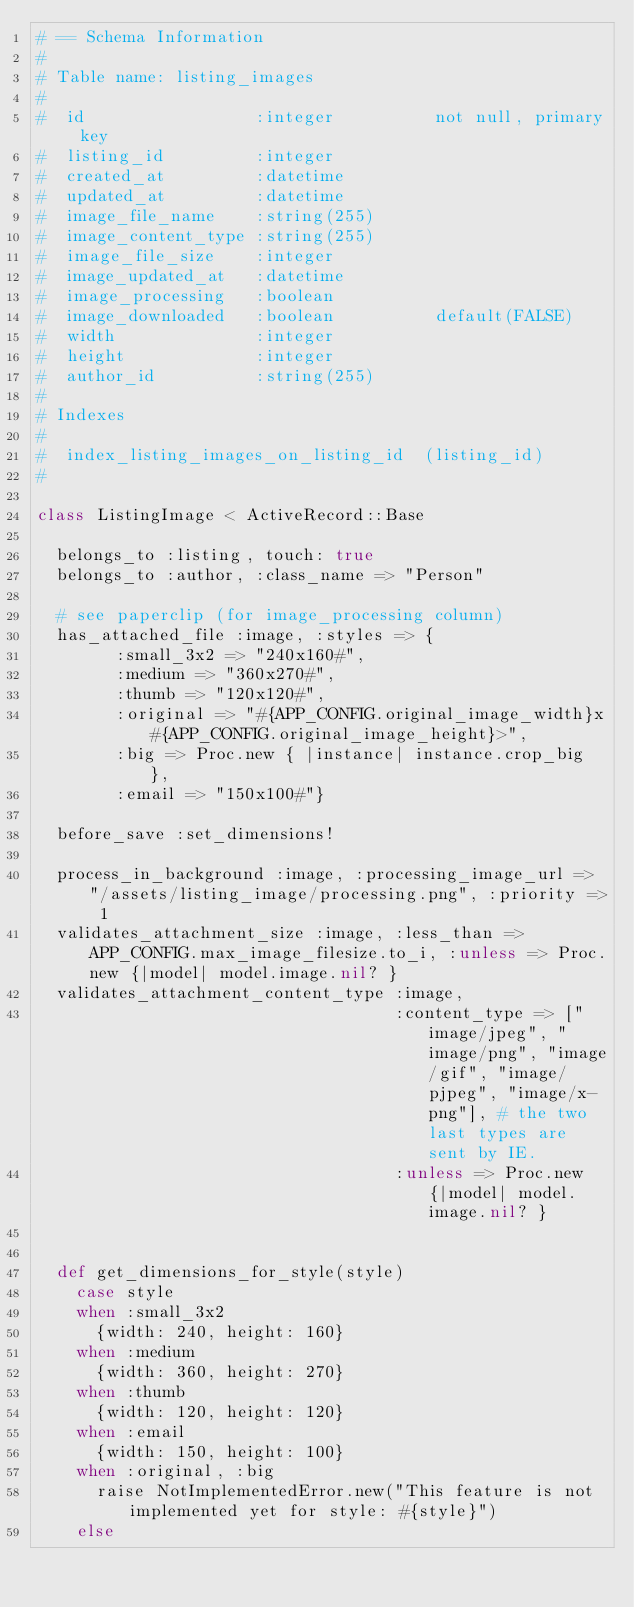Convert code to text. <code><loc_0><loc_0><loc_500><loc_500><_Ruby_># == Schema Information
#
# Table name: listing_images
#
#  id                 :integer          not null, primary key
#  listing_id         :integer
#  created_at         :datetime
#  updated_at         :datetime
#  image_file_name    :string(255)
#  image_content_type :string(255)
#  image_file_size    :integer
#  image_updated_at   :datetime
#  image_processing   :boolean
#  image_downloaded   :boolean          default(FALSE)
#  width              :integer
#  height             :integer
#  author_id          :string(255)
#
# Indexes
#
#  index_listing_images_on_listing_id  (listing_id)
#

class ListingImage < ActiveRecord::Base

  belongs_to :listing, touch: true
  belongs_to :author, :class_name => "Person"

  # see paperclip (for image_processing column)
  has_attached_file :image, :styles => {
        :small_3x2 => "240x160#",
        :medium => "360x270#",
        :thumb => "120x120#",
        :original => "#{APP_CONFIG.original_image_width}x#{APP_CONFIG.original_image_height}>",
        :big => Proc.new { |instance| instance.crop_big },
        :email => "150x100#"}

  before_save :set_dimensions!

  process_in_background :image, :processing_image_url => "/assets/listing_image/processing.png", :priority => 1
  validates_attachment_size :image, :less_than => APP_CONFIG.max_image_filesize.to_i, :unless => Proc.new {|model| model.image.nil? }
  validates_attachment_content_type :image,
                                    :content_type => ["image/jpeg", "image/png", "image/gif", "image/pjpeg", "image/x-png"], # the two last types are sent by IE.
                                    :unless => Proc.new {|model| model.image.nil? }


  def get_dimensions_for_style(style)
    case style
    when :small_3x2
      {width: 240, height: 160}
    when :medium
      {width: 360, height: 270}
    when :thumb
      {width: 120, height: 120}
    when :email
      {width: 150, height: 100}
    when :original, :big
      raise NotImplementedError.new("This feature is not implemented yet for style: #{style}")
    else</code> 